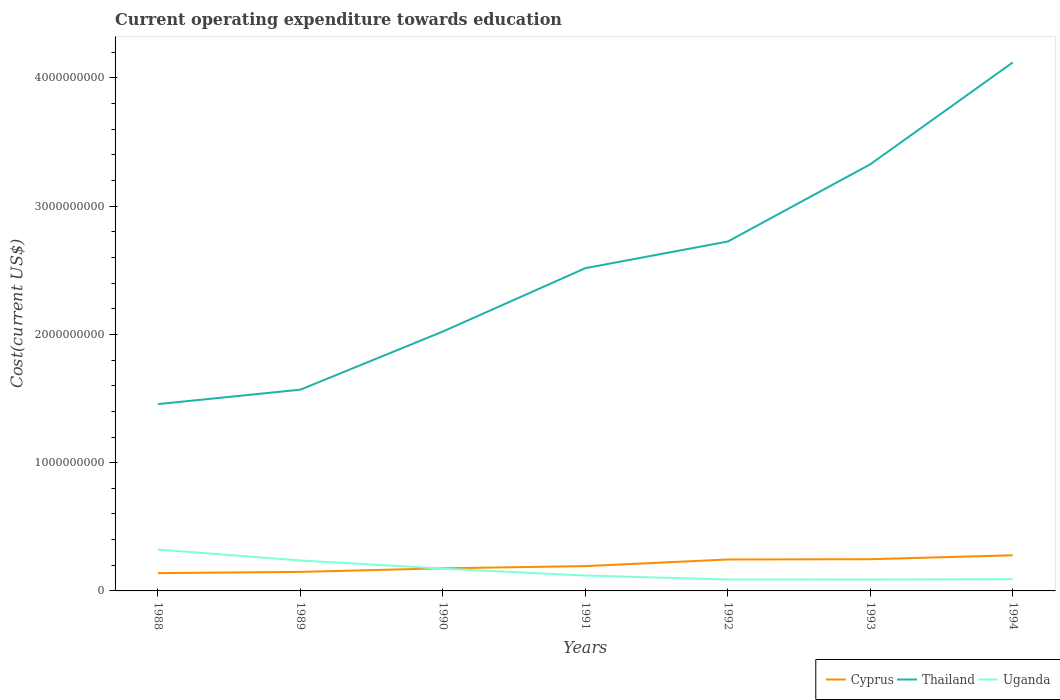How many different coloured lines are there?
Ensure brevity in your answer.  3. Does the line corresponding to Cyprus intersect with the line corresponding to Uganda?
Your answer should be very brief. Yes. Is the number of lines equal to the number of legend labels?
Provide a succinct answer. Yes. Across all years, what is the maximum expenditure towards education in Thailand?
Give a very brief answer. 1.46e+09. What is the total expenditure towards education in Uganda in the graph?
Offer a very short reply. 5.41e+07. What is the difference between the highest and the second highest expenditure towards education in Thailand?
Make the answer very short. 2.66e+09. How many years are there in the graph?
Your answer should be very brief. 7. What is the difference between two consecutive major ticks on the Y-axis?
Your answer should be compact. 1.00e+09. Are the values on the major ticks of Y-axis written in scientific E-notation?
Give a very brief answer. No. Does the graph contain any zero values?
Your answer should be compact. No. How are the legend labels stacked?
Give a very brief answer. Horizontal. What is the title of the graph?
Your answer should be compact. Current operating expenditure towards education. Does "Micronesia" appear as one of the legend labels in the graph?
Offer a very short reply. No. What is the label or title of the X-axis?
Your answer should be very brief. Years. What is the label or title of the Y-axis?
Offer a terse response. Cost(current US$). What is the Cost(current US$) in Cyprus in 1988?
Your response must be concise. 1.39e+08. What is the Cost(current US$) in Thailand in 1988?
Offer a very short reply. 1.46e+09. What is the Cost(current US$) in Uganda in 1988?
Provide a succinct answer. 3.23e+08. What is the Cost(current US$) in Cyprus in 1989?
Your response must be concise. 1.48e+08. What is the Cost(current US$) in Thailand in 1989?
Give a very brief answer. 1.57e+09. What is the Cost(current US$) of Uganda in 1989?
Provide a short and direct response. 2.37e+08. What is the Cost(current US$) of Cyprus in 1990?
Your response must be concise. 1.76e+08. What is the Cost(current US$) of Thailand in 1990?
Offer a terse response. 2.02e+09. What is the Cost(current US$) of Uganda in 1990?
Offer a terse response. 1.74e+08. What is the Cost(current US$) in Cyprus in 1991?
Offer a terse response. 1.94e+08. What is the Cost(current US$) in Thailand in 1991?
Your answer should be compact. 2.52e+09. What is the Cost(current US$) of Uganda in 1991?
Your answer should be compact. 1.20e+08. What is the Cost(current US$) of Cyprus in 1992?
Provide a short and direct response. 2.45e+08. What is the Cost(current US$) of Thailand in 1992?
Make the answer very short. 2.72e+09. What is the Cost(current US$) in Uganda in 1992?
Provide a succinct answer. 8.94e+07. What is the Cost(current US$) of Cyprus in 1993?
Make the answer very short. 2.47e+08. What is the Cost(current US$) in Thailand in 1993?
Make the answer very short. 3.33e+09. What is the Cost(current US$) of Uganda in 1993?
Make the answer very short. 8.84e+07. What is the Cost(current US$) of Cyprus in 1994?
Keep it short and to the point. 2.78e+08. What is the Cost(current US$) in Thailand in 1994?
Your answer should be compact. 4.12e+09. What is the Cost(current US$) of Uganda in 1994?
Offer a very short reply. 9.21e+07. Across all years, what is the maximum Cost(current US$) in Cyprus?
Make the answer very short. 2.78e+08. Across all years, what is the maximum Cost(current US$) in Thailand?
Keep it short and to the point. 4.12e+09. Across all years, what is the maximum Cost(current US$) of Uganda?
Provide a short and direct response. 3.23e+08. Across all years, what is the minimum Cost(current US$) of Cyprus?
Provide a short and direct response. 1.39e+08. Across all years, what is the minimum Cost(current US$) of Thailand?
Make the answer very short. 1.46e+09. Across all years, what is the minimum Cost(current US$) of Uganda?
Offer a terse response. 8.84e+07. What is the total Cost(current US$) in Cyprus in the graph?
Your response must be concise. 1.43e+09. What is the total Cost(current US$) of Thailand in the graph?
Make the answer very short. 1.77e+1. What is the total Cost(current US$) in Uganda in the graph?
Ensure brevity in your answer.  1.12e+09. What is the difference between the Cost(current US$) of Cyprus in 1988 and that in 1989?
Give a very brief answer. -9.60e+06. What is the difference between the Cost(current US$) in Thailand in 1988 and that in 1989?
Offer a terse response. -1.13e+08. What is the difference between the Cost(current US$) of Uganda in 1988 and that in 1989?
Offer a very short reply. 8.51e+07. What is the difference between the Cost(current US$) in Cyprus in 1988 and that in 1990?
Ensure brevity in your answer.  -3.74e+07. What is the difference between the Cost(current US$) in Thailand in 1988 and that in 1990?
Your response must be concise. -5.66e+08. What is the difference between the Cost(current US$) of Uganda in 1988 and that in 1990?
Keep it short and to the point. 1.49e+08. What is the difference between the Cost(current US$) of Cyprus in 1988 and that in 1991?
Keep it short and to the point. -5.49e+07. What is the difference between the Cost(current US$) in Thailand in 1988 and that in 1991?
Ensure brevity in your answer.  -1.06e+09. What is the difference between the Cost(current US$) in Uganda in 1988 and that in 1991?
Give a very brief answer. 2.03e+08. What is the difference between the Cost(current US$) of Cyprus in 1988 and that in 1992?
Provide a short and direct response. -1.06e+08. What is the difference between the Cost(current US$) of Thailand in 1988 and that in 1992?
Make the answer very short. -1.27e+09. What is the difference between the Cost(current US$) of Uganda in 1988 and that in 1992?
Make the answer very short. 2.33e+08. What is the difference between the Cost(current US$) of Cyprus in 1988 and that in 1993?
Your answer should be compact. -1.09e+08. What is the difference between the Cost(current US$) in Thailand in 1988 and that in 1993?
Give a very brief answer. -1.87e+09. What is the difference between the Cost(current US$) of Uganda in 1988 and that in 1993?
Give a very brief answer. 2.34e+08. What is the difference between the Cost(current US$) in Cyprus in 1988 and that in 1994?
Offer a terse response. -1.39e+08. What is the difference between the Cost(current US$) in Thailand in 1988 and that in 1994?
Provide a short and direct response. -2.66e+09. What is the difference between the Cost(current US$) in Uganda in 1988 and that in 1994?
Your response must be concise. 2.31e+08. What is the difference between the Cost(current US$) of Cyprus in 1989 and that in 1990?
Your answer should be compact. -2.78e+07. What is the difference between the Cost(current US$) of Thailand in 1989 and that in 1990?
Your answer should be very brief. -4.53e+08. What is the difference between the Cost(current US$) in Uganda in 1989 and that in 1990?
Provide a short and direct response. 6.35e+07. What is the difference between the Cost(current US$) in Cyprus in 1989 and that in 1991?
Offer a very short reply. -4.53e+07. What is the difference between the Cost(current US$) of Thailand in 1989 and that in 1991?
Make the answer very short. -9.47e+08. What is the difference between the Cost(current US$) of Uganda in 1989 and that in 1991?
Ensure brevity in your answer.  1.18e+08. What is the difference between the Cost(current US$) in Cyprus in 1989 and that in 1992?
Provide a succinct answer. -9.66e+07. What is the difference between the Cost(current US$) of Thailand in 1989 and that in 1992?
Offer a terse response. -1.16e+09. What is the difference between the Cost(current US$) of Uganda in 1989 and that in 1992?
Provide a short and direct response. 1.48e+08. What is the difference between the Cost(current US$) in Cyprus in 1989 and that in 1993?
Give a very brief answer. -9.90e+07. What is the difference between the Cost(current US$) of Thailand in 1989 and that in 1993?
Give a very brief answer. -1.76e+09. What is the difference between the Cost(current US$) in Uganda in 1989 and that in 1993?
Keep it short and to the point. 1.49e+08. What is the difference between the Cost(current US$) in Cyprus in 1989 and that in 1994?
Keep it short and to the point. -1.30e+08. What is the difference between the Cost(current US$) in Thailand in 1989 and that in 1994?
Provide a succinct answer. -2.55e+09. What is the difference between the Cost(current US$) of Uganda in 1989 and that in 1994?
Give a very brief answer. 1.45e+08. What is the difference between the Cost(current US$) of Cyprus in 1990 and that in 1991?
Ensure brevity in your answer.  -1.75e+07. What is the difference between the Cost(current US$) in Thailand in 1990 and that in 1991?
Give a very brief answer. -4.94e+08. What is the difference between the Cost(current US$) of Uganda in 1990 and that in 1991?
Provide a succinct answer. 5.41e+07. What is the difference between the Cost(current US$) of Cyprus in 1990 and that in 1992?
Your answer should be compact. -6.88e+07. What is the difference between the Cost(current US$) in Thailand in 1990 and that in 1992?
Your answer should be very brief. -7.02e+08. What is the difference between the Cost(current US$) of Uganda in 1990 and that in 1992?
Ensure brevity in your answer.  8.45e+07. What is the difference between the Cost(current US$) in Cyprus in 1990 and that in 1993?
Provide a succinct answer. -7.12e+07. What is the difference between the Cost(current US$) of Thailand in 1990 and that in 1993?
Make the answer very short. -1.30e+09. What is the difference between the Cost(current US$) in Uganda in 1990 and that in 1993?
Your response must be concise. 8.56e+07. What is the difference between the Cost(current US$) of Cyprus in 1990 and that in 1994?
Offer a terse response. -1.02e+08. What is the difference between the Cost(current US$) in Thailand in 1990 and that in 1994?
Keep it short and to the point. -2.10e+09. What is the difference between the Cost(current US$) in Uganda in 1990 and that in 1994?
Your answer should be very brief. 8.19e+07. What is the difference between the Cost(current US$) in Cyprus in 1991 and that in 1992?
Offer a terse response. -5.14e+07. What is the difference between the Cost(current US$) in Thailand in 1991 and that in 1992?
Your response must be concise. -2.08e+08. What is the difference between the Cost(current US$) of Uganda in 1991 and that in 1992?
Offer a terse response. 3.04e+07. What is the difference between the Cost(current US$) in Cyprus in 1991 and that in 1993?
Provide a succinct answer. -5.38e+07. What is the difference between the Cost(current US$) of Thailand in 1991 and that in 1993?
Give a very brief answer. -8.10e+08. What is the difference between the Cost(current US$) of Uganda in 1991 and that in 1993?
Your answer should be very brief. 3.15e+07. What is the difference between the Cost(current US$) of Cyprus in 1991 and that in 1994?
Your answer should be compact. -8.43e+07. What is the difference between the Cost(current US$) of Thailand in 1991 and that in 1994?
Offer a terse response. -1.60e+09. What is the difference between the Cost(current US$) in Uganda in 1991 and that in 1994?
Offer a very short reply. 2.78e+07. What is the difference between the Cost(current US$) of Cyprus in 1992 and that in 1993?
Give a very brief answer. -2.40e+06. What is the difference between the Cost(current US$) of Thailand in 1992 and that in 1993?
Give a very brief answer. -6.02e+08. What is the difference between the Cost(current US$) of Uganda in 1992 and that in 1993?
Provide a short and direct response. 1.10e+06. What is the difference between the Cost(current US$) of Cyprus in 1992 and that in 1994?
Keep it short and to the point. -3.29e+07. What is the difference between the Cost(current US$) in Thailand in 1992 and that in 1994?
Make the answer very short. -1.40e+09. What is the difference between the Cost(current US$) in Uganda in 1992 and that in 1994?
Make the answer very short. -2.61e+06. What is the difference between the Cost(current US$) of Cyprus in 1993 and that in 1994?
Ensure brevity in your answer.  -3.05e+07. What is the difference between the Cost(current US$) in Thailand in 1993 and that in 1994?
Your answer should be very brief. -7.94e+08. What is the difference between the Cost(current US$) of Uganda in 1993 and that in 1994?
Offer a very short reply. -3.71e+06. What is the difference between the Cost(current US$) in Cyprus in 1988 and the Cost(current US$) in Thailand in 1989?
Keep it short and to the point. -1.43e+09. What is the difference between the Cost(current US$) in Cyprus in 1988 and the Cost(current US$) in Uganda in 1989?
Make the answer very short. -9.87e+07. What is the difference between the Cost(current US$) of Thailand in 1988 and the Cost(current US$) of Uganda in 1989?
Keep it short and to the point. 1.22e+09. What is the difference between the Cost(current US$) in Cyprus in 1988 and the Cost(current US$) in Thailand in 1990?
Keep it short and to the point. -1.88e+09. What is the difference between the Cost(current US$) of Cyprus in 1988 and the Cost(current US$) of Uganda in 1990?
Offer a very short reply. -3.52e+07. What is the difference between the Cost(current US$) of Thailand in 1988 and the Cost(current US$) of Uganda in 1990?
Your answer should be compact. 1.28e+09. What is the difference between the Cost(current US$) of Cyprus in 1988 and the Cost(current US$) of Thailand in 1991?
Provide a succinct answer. -2.38e+09. What is the difference between the Cost(current US$) of Cyprus in 1988 and the Cost(current US$) of Uganda in 1991?
Your answer should be compact. 1.89e+07. What is the difference between the Cost(current US$) in Thailand in 1988 and the Cost(current US$) in Uganda in 1991?
Your answer should be very brief. 1.34e+09. What is the difference between the Cost(current US$) of Cyprus in 1988 and the Cost(current US$) of Thailand in 1992?
Provide a short and direct response. -2.59e+09. What is the difference between the Cost(current US$) of Cyprus in 1988 and the Cost(current US$) of Uganda in 1992?
Ensure brevity in your answer.  4.93e+07. What is the difference between the Cost(current US$) in Thailand in 1988 and the Cost(current US$) in Uganda in 1992?
Make the answer very short. 1.37e+09. What is the difference between the Cost(current US$) of Cyprus in 1988 and the Cost(current US$) of Thailand in 1993?
Give a very brief answer. -3.19e+09. What is the difference between the Cost(current US$) of Cyprus in 1988 and the Cost(current US$) of Uganda in 1993?
Your answer should be very brief. 5.04e+07. What is the difference between the Cost(current US$) in Thailand in 1988 and the Cost(current US$) in Uganda in 1993?
Your response must be concise. 1.37e+09. What is the difference between the Cost(current US$) of Cyprus in 1988 and the Cost(current US$) of Thailand in 1994?
Offer a very short reply. -3.98e+09. What is the difference between the Cost(current US$) in Cyprus in 1988 and the Cost(current US$) in Uganda in 1994?
Make the answer very short. 4.67e+07. What is the difference between the Cost(current US$) in Thailand in 1988 and the Cost(current US$) in Uganda in 1994?
Offer a very short reply. 1.36e+09. What is the difference between the Cost(current US$) in Cyprus in 1989 and the Cost(current US$) in Thailand in 1990?
Offer a very short reply. -1.87e+09. What is the difference between the Cost(current US$) of Cyprus in 1989 and the Cost(current US$) of Uganda in 1990?
Your answer should be compact. -2.56e+07. What is the difference between the Cost(current US$) of Thailand in 1989 and the Cost(current US$) of Uganda in 1990?
Offer a terse response. 1.40e+09. What is the difference between the Cost(current US$) in Cyprus in 1989 and the Cost(current US$) in Thailand in 1991?
Provide a short and direct response. -2.37e+09. What is the difference between the Cost(current US$) of Cyprus in 1989 and the Cost(current US$) of Uganda in 1991?
Ensure brevity in your answer.  2.85e+07. What is the difference between the Cost(current US$) in Thailand in 1989 and the Cost(current US$) in Uganda in 1991?
Offer a very short reply. 1.45e+09. What is the difference between the Cost(current US$) in Cyprus in 1989 and the Cost(current US$) in Thailand in 1992?
Give a very brief answer. -2.58e+09. What is the difference between the Cost(current US$) in Cyprus in 1989 and the Cost(current US$) in Uganda in 1992?
Keep it short and to the point. 5.89e+07. What is the difference between the Cost(current US$) of Thailand in 1989 and the Cost(current US$) of Uganda in 1992?
Keep it short and to the point. 1.48e+09. What is the difference between the Cost(current US$) in Cyprus in 1989 and the Cost(current US$) in Thailand in 1993?
Your answer should be very brief. -3.18e+09. What is the difference between the Cost(current US$) in Cyprus in 1989 and the Cost(current US$) in Uganda in 1993?
Your answer should be very brief. 6.00e+07. What is the difference between the Cost(current US$) of Thailand in 1989 and the Cost(current US$) of Uganda in 1993?
Offer a very short reply. 1.48e+09. What is the difference between the Cost(current US$) of Cyprus in 1989 and the Cost(current US$) of Thailand in 1994?
Offer a terse response. -3.97e+09. What is the difference between the Cost(current US$) in Cyprus in 1989 and the Cost(current US$) in Uganda in 1994?
Provide a short and direct response. 5.63e+07. What is the difference between the Cost(current US$) in Thailand in 1989 and the Cost(current US$) in Uganda in 1994?
Ensure brevity in your answer.  1.48e+09. What is the difference between the Cost(current US$) of Cyprus in 1990 and the Cost(current US$) of Thailand in 1991?
Provide a succinct answer. -2.34e+09. What is the difference between the Cost(current US$) of Cyprus in 1990 and the Cost(current US$) of Uganda in 1991?
Your answer should be very brief. 5.63e+07. What is the difference between the Cost(current US$) of Thailand in 1990 and the Cost(current US$) of Uganda in 1991?
Provide a short and direct response. 1.90e+09. What is the difference between the Cost(current US$) in Cyprus in 1990 and the Cost(current US$) in Thailand in 1992?
Your answer should be very brief. -2.55e+09. What is the difference between the Cost(current US$) in Cyprus in 1990 and the Cost(current US$) in Uganda in 1992?
Your answer should be very brief. 8.67e+07. What is the difference between the Cost(current US$) in Thailand in 1990 and the Cost(current US$) in Uganda in 1992?
Keep it short and to the point. 1.93e+09. What is the difference between the Cost(current US$) in Cyprus in 1990 and the Cost(current US$) in Thailand in 1993?
Give a very brief answer. -3.15e+09. What is the difference between the Cost(current US$) in Cyprus in 1990 and the Cost(current US$) in Uganda in 1993?
Offer a terse response. 8.78e+07. What is the difference between the Cost(current US$) in Thailand in 1990 and the Cost(current US$) in Uganda in 1993?
Offer a terse response. 1.93e+09. What is the difference between the Cost(current US$) of Cyprus in 1990 and the Cost(current US$) of Thailand in 1994?
Offer a terse response. -3.94e+09. What is the difference between the Cost(current US$) in Cyprus in 1990 and the Cost(current US$) in Uganda in 1994?
Provide a short and direct response. 8.41e+07. What is the difference between the Cost(current US$) in Thailand in 1990 and the Cost(current US$) in Uganda in 1994?
Offer a terse response. 1.93e+09. What is the difference between the Cost(current US$) in Cyprus in 1991 and the Cost(current US$) in Thailand in 1992?
Your answer should be very brief. -2.53e+09. What is the difference between the Cost(current US$) in Cyprus in 1991 and the Cost(current US$) in Uganda in 1992?
Your answer should be compact. 1.04e+08. What is the difference between the Cost(current US$) of Thailand in 1991 and the Cost(current US$) of Uganda in 1992?
Ensure brevity in your answer.  2.43e+09. What is the difference between the Cost(current US$) in Cyprus in 1991 and the Cost(current US$) in Thailand in 1993?
Ensure brevity in your answer.  -3.13e+09. What is the difference between the Cost(current US$) of Cyprus in 1991 and the Cost(current US$) of Uganda in 1993?
Keep it short and to the point. 1.05e+08. What is the difference between the Cost(current US$) in Thailand in 1991 and the Cost(current US$) in Uganda in 1993?
Keep it short and to the point. 2.43e+09. What is the difference between the Cost(current US$) of Cyprus in 1991 and the Cost(current US$) of Thailand in 1994?
Provide a short and direct response. -3.93e+09. What is the difference between the Cost(current US$) of Cyprus in 1991 and the Cost(current US$) of Uganda in 1994?
Offer a very short reply. 1.02e+08. What is the difference between the Cost(current US$) of Thailand in 1991 and the Cost(current US$) of Uganda in 1994?
Keep it short and to the point. 2.42e+09. What is the difference between the Cost(current US$) of Cyprus in 1992 and the Cost(current US$) of Thailand in 1993?
Your response must be concise. -3.08e+09. What is the difference between the Cost(current US$) in Cyprus in 1992 and the Cost(current US$) in Uganda in 1993?
Ensure brevity in your answer.  1.57e+08. What is the difference between the Cost(current US$) of Thailand in 1992 and the Cost(current US$) of Uganda in 1993?
Your answer should be very brief. 2.64e+09. What is the difference between the Cost(current US$) of Cyprus in 1992 and the Cost(current US$) of Thailand in 1994?
Your answer should be compact. -3.88e+09. What is the difference between the Cost(current US$) of Cyprus in 1992 and the Cost(current US$) of Uganda in 1994?
Provide a succinct answer. 1.53e+08. What is the difference between the Cost(current US$) in Thailand in 1992 and the Cost(current US$) in Uganda in 1994?
Offer a very short reply. 2.63e+09. What is the difference between the Cost(current US$) in Cyprus in 1993 and the Cost(current US$) in Thailand in 1994?
Make the answer very short. -3.87e+09. What is the difference between the Cost(current US$) of Cyprus in 1993 and the Cost(current US$) of Uganda in 1994?
Your answer should be compact. 1.55e+08. What is the difference between the Cost(current US$) of Thailand in 1993 and the Cost(current US$) of Uganda in 1994?
Keep it short and to the point. 3.23e+09. What is the average Cost(current US$) in Cyprus per year?
Keep it short and to the point. 2.04e+08. What is the average Cost(current US$) in Thailand per year?
Offer a very short reply. 2.53e+09. What is the average Cost(current US$) in Uganda per year?
Ensure brevity in your answer.  1.61e+08. In the year 1988, what is the difference between the Cost(current US$) in Cyprus and Cost(current US$) in Thailand?
Make the answer very short. -1.32e+09. In the year 1988, what is the difference between the Cost(current US$) of Cyprus and Cost(current US$) of Uganda?
Offer a terse response. -1.84e+08. In the year 1988, what is the difference between the Cost(current US$) of Thailand and Cost(current US$) of Uganda?
Make the answer very short. 1.13e+09. In the year 1989, what is the difference between the Cost(current US$) of Cyprus and Cost(current US$) of Thailand?
Ensure brevity in your answer.  -1.42e+09. In the year 1989, what is the difference between the Cost(current US$) in Cyprus and Cost(current US$) in Uganda?
Your answer should be very brief. -8.91e+07. In the year 1989, what is the difference between the Cost(current US$) of Thailand and Cost(current US$) of Uganda?
Your answer should be very brief. 1.33e+09. In the year 1990, what is the difference between the Cost(current US$) of Cyprus and Cost(current US$) of Thailand?
Your response must be concise. -1.85e+09. In the year 1990, what is the difference between the Cost(current US$) of Cyprus and Cost(current US$) of Uganda?
Make the answer very short. 2.22e+06. In the year 1990, what is the difference between the Cost(current US$) in Thailand and Cost(current US$) in Uganda?
Offer a very short reply. 1.85e+09. In the year 1991, what is the difference between the Cost(current US$) of Cyprus and Cost(current US$) of Thailand?
Keep it short and to the point. -2.32e+09. In the year 1991, what is the difference between the Cost(current US$) of Cyprus and Cost(current US$) of Uganda?
Provide a short and direct response. 7.38e+07. In the year 1991, what is the difference between the Cost(current US$) of Thailand and Cost(current US$) of Uganda?
Your response must be concise. 2.40e+09. In the year 1992, what is the difference between the Cost(current US$) in Cyprus and Cost(current US$) in Thailand?
Ensure brevity in your answer.  -2.48e+09. In the year 1992, what is the difference between the Cost(current US$) of Cyprus and Cost(current US$) of Uganda?
Provide a succinct answer. 1.56e+08. In the year 1992, what is the difference between the Cost(current US$) of Thailand and Cost(current US$) of Uganda?
Provide a succinct answer. 2.63e+09. In the year 1993, what is the difference between the Cost(current US$) in Cyprus and Cost(current US$) in Thailand?
Make the answer very short. -3.08e+09. In the year 1993, what is the difference between the Cost(current US$) in Cyprus and Cost(current US$) in Uganda?
Offer a very short reply. 1.59e+08. In the year 1993, what is the difference between the Cost(current US$) of Thailand and Cost(current US$) of Uganda?
Ensure brevity in your answer.  3.24e+09. In the year 1994, what is the difference between the Cost(current US$) of Cyprus and Cost(current US$) of Thailand?
Provide a short and direct response. -3.84e+09. In the year 1994, what is the difference between the Cost(current US$) in Cyprus and Cost(current US$) in Uganda?
Your response must be concise. 1.86e+08. In the year 1994, what is the difference between the Cost(current US$) in Thailand and Cost(current US$) in Uganda?
Give a very brief answer. 4.03e+09. What is the ratio of the Cost(current US$) of Cyprus in 1988 to that in 1989?
Your answer should be compact. 0.94. What is the ratio of the Cost(current US$) in Thailand in 1988 to that in 1989?
Ensure brevity in your answer.  0.93. What is the ratio of the Cost(current US$) in Uganda in 1988 to that in 1989?
Keep it short and to the point. 1.36. What is the ratio of the Cost(current US$) of Cyprus in 1988 to that in 1990?
Make the answer very short. 0.79. What is the ratio of the Cost(current US$) of Thailand in 1988 to that in 1990?
Offer a very short reply. 0.72. What is the ratio of the Cost(current US$) in Uganda in 1988 to that in 1990?
Provide a succinct answer. 1.85. What is the ratio of the Cost(current US$) in Cyprus in 1988 to that in 1991?
Give a very brief answer. 0.72. What is the ratio of the Cost(current US$) of Thailand in 1988 to that in 1991?
Provide a short and direct response. 0.58. What is the ratio of the Cost(current US$) of Uganda in 1988 to that in 1991?
Give a very brief answer. 2.69. What is the ratio of the Cost(current US$) in Cyprus in 1988 to that in 1992?
Give a very brief answer. 0.57. What is the ratio of the Cost(current US$) in Thailand in 1988 to that in 1992?
Ensure brevity in your answer.  0.53. What is the ratio of the Cost(current US$) in Uganda in 1988 to that in 1992?
Provide a succinct answer. 3.61. What is the ratio of the Cost(current US$) in Cyprus in 1988 to that in 1993?
Your answer should be compact. 0.56. What is the ratio of the Cost(current US$) of Thailand in 1988 to that in 1993?
Make the answer very short. 0.44. What is the ratio of the Cost(current US$) of Uganda in 1988 to that in 1993?
Offer a very short reply. 3.65. What is the ratio of the Cost(current US$) of Cyprus in 1988 to that in 1994?
Give a very brief answer. 0.5. What is the ratio of the Cost(current US$) in Thailand in 1988 to that in 1994?
Keep it short and to the point. 0.35. What is the ratio of the Cost(current US$) of Uganda in 1988 to that in 1994?
Your answer should be compact. 3.5. What is the ratio of the Cost(current US$) in Cyprus in 1989 to that in 1990?
Ensure brevity in your answer.  0.84. What is the ratio of the Cost(current US$) in Thailand in 1989 to that in 1990?
Your answer should be very brief. 0.78. What is the ratio of the Cost(current US$) of Uganda in 1989 to that in 1990?
Give a very brief answer. 1.37. What is the ratio of the Cost(current US$) in Cyprus in 1989 to that in 1991?
Your response must be concise. 0.77. What is the ratio of the Cost(current US$) in Thailand in 1989 to that in 1991?
Provide a short and direct response. 0.62. What is the ratio of the Cost(current US$) in Uganda in 1989 to that in 1991?
Give a very brief answer. 1.98. What is the ratio of the Cost(current US$) in Cyprus in 1989 to that in 1992?
Your response must be concise. 0.61. What is the ratio of the Cost(current US$) in Thailand in 1989 to that in 1992?
Your answer should be very brief. 0.58. What is the ratio of the Cost(current US$) in Uganda in 1989 to that in 1992?
Make the answer very short. 2.65. What is the ratio of the Cost(current US$) of Cyprus in 1989 to that in 1993?
Your answer should be compact. 0.6. What is the ratio of the Cost(current US$) of Thailand in 1989 to that in 1993?
Offer a terse response. 0.47. What is the ratio of the Cost(current US$) in Uganda in 1989 to that in 1993?
Make the answer very short. 2.69. What is the ratio of the Cost(current US$) in Cyprus in 1989 to that in 1994?
Provide a short and direct response. 0.53. What is the ratio of the Cost(current US$) in Thailand in 1989 to that in 1994?
Make the answer very short. 0.38. What is the ratio of the Cost(current US$) in Uganda in 1989 to that in 1994?
Offer a terse response. 2.58. What is the ratio of the Cost(current US$) of Cyprus in 1990 to that in 1991?
Ensure brevity in your answer.  0.91. What is the ratio of the Cost(current US$) in Thailand in 1990 to that in 1991?
Make the answer very short. 0.8. What is the ratio of the Cost(current US$) in Uganda in 1990 to that in 1991?
Make the answer very short. 1.45. What is the ratio of the Cost(current US$) in Cyprus in 1990 to that in 1992?
Give a very brief answer. 0.72. What is the ratio of the Cost(current US$) in Thailand in 1990 to that in 1992?
Make the answer very short. 0.74. What is the ratio of the Cost(current US$) in Uganda in 1990 to that in 1992?
Offer a very short reply. 1.94. What is the ratio of the Cost(current US$) of Cyprus in 1990 to that in 1993?
Make the answer very short. 0.71. What is the ratio of the Cost(current US$) in Thailand in 1990 to that in 1993?
Keep it short and to the point. 0.61. What is the ratio of the Cost(current US$) in Uganda in 1990 to that in 1993?
Offer a very short reply. 1.97. What is the ratio of the Cost(current US$) in Cyprus in 1990 to that in 1994?
Your answer should be compact. 0.63. What is the ratio of the Cost(current US$) of Thailand in 1990 to that in 1994?
Your answer should be compact. 0.49. What is the ratio of the Cost(current US$) of Uganda in 1990 to that in 1994?
Keep it short and to the point. 1.89. What is the ratio of the Cost(current US$) of Cyprus in 1991 to that in 1992?
Make the answer very short. 0.79. What is the ratio of the Cost(current US$) in Thailand in 1991 to that in 1992?
Keep it short and to the point. 0.92. What is the ratio of the Cost(current US$) of Uganda in 1991 to that in 1992?
Offer a terse response. 1.34. What is the ratio of the Cost(current US$) in Cyprus in 1991 to that in 1993?
Offer a terse response. 0.78. What is the ratio of the Cost(current US$) of Thailand in 1991 to that in 1993?
Make the answer very short. 0.76. What is the ratio of the Cost(current US$) in Uganda in 1991 to that in 1993?
Provide a short and direct response. 1.36. What is the ratio of the Cost(current US$) of Cyprus in 1991 to that in 1994?
Your response must be concise. 0.7. What is the ratio of the Cost(current US$) of Thailand in 1991 to that in 1994?
Make the answer very short. 0.61. What is the ratio of the Cost(current US$) of Uganda in 1991 to that in 1994?
Make the answer very short. 1.3. What is the ratio of the Cost(current US$) of Cyprus in 1992 to that in 1993?
Your response must be concise. 0.99. What is the ratio of the Cost(current US$) in Thailand in 1992 to that in 1993?
Your answer should be very brief. 0.82. What is the ratio of the Cost(current US$) of Uganda in 1992 to that in 1993?
Offer a terse response. 1.01. What is the ratio of the Cost(current US$) of Cyprus in 1992 to that in 1994?
Your answer should be very brief. 0.88. What is the ratio of the Cost(current US$) in Thailand in 1992 to that in 1994?
Your answer should be compact. 0.66. What is the ratio of the Cost(current US$) in Uganda in 1992 to that in 1994?
Make the answer very short. 0.97. What is the ratio of the Cost(current US$) in Cyprus in 1993 to that in 1994?
Your answer should be very brief. 0.89. What is the ratio of the Cost(current US$) in Thailand in 1993 to that in 1994?
Your answer should be compact. 0.81. What is the ratio of the Cost(current US$) of Uganda in 1993 to that in 1994?
Provide a succinct answer. 0.96. What is the difference between the highest and the second highest Cost(current US$) in Cyprus?
Make the answer very short. 3.05e+07. What is the difference between the highest and the second highest Cost(current US$) in Thailand?
Your answer should be compact. 7.94e+08. What is the difference between the highest and the second highest Cost(current US$) in Uganda?
Provide a short and direct response. 8.51e+07. What is the difference between the highest and the lowest Cost(current US$) of Cyprus?
Provide a succinct answer. 1.39e+08. What is the difference between the highest and the lowest Cost(current US$) of Thailand?
Give a very brief answer. 2.66e+09. What is the difference between the highest and the lowest Cost(current US$) in Uganda?
Offer a terse response. 2.34e+08. 